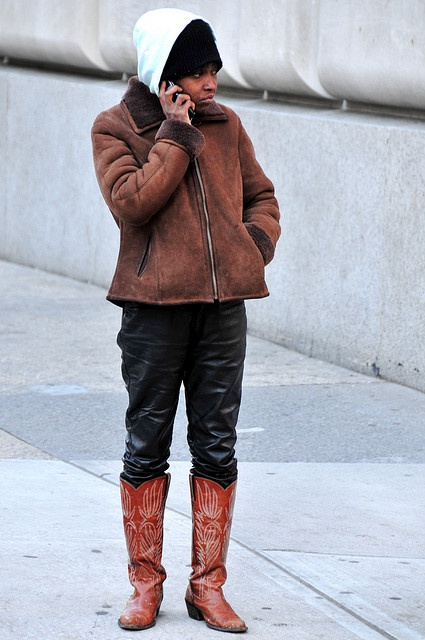Describe the objects in this image and their specific colors. I can see people in lightgray, black, brown, and maroon tones and cell phone in lightgray, black, gray, and darkgray tones in this image. 